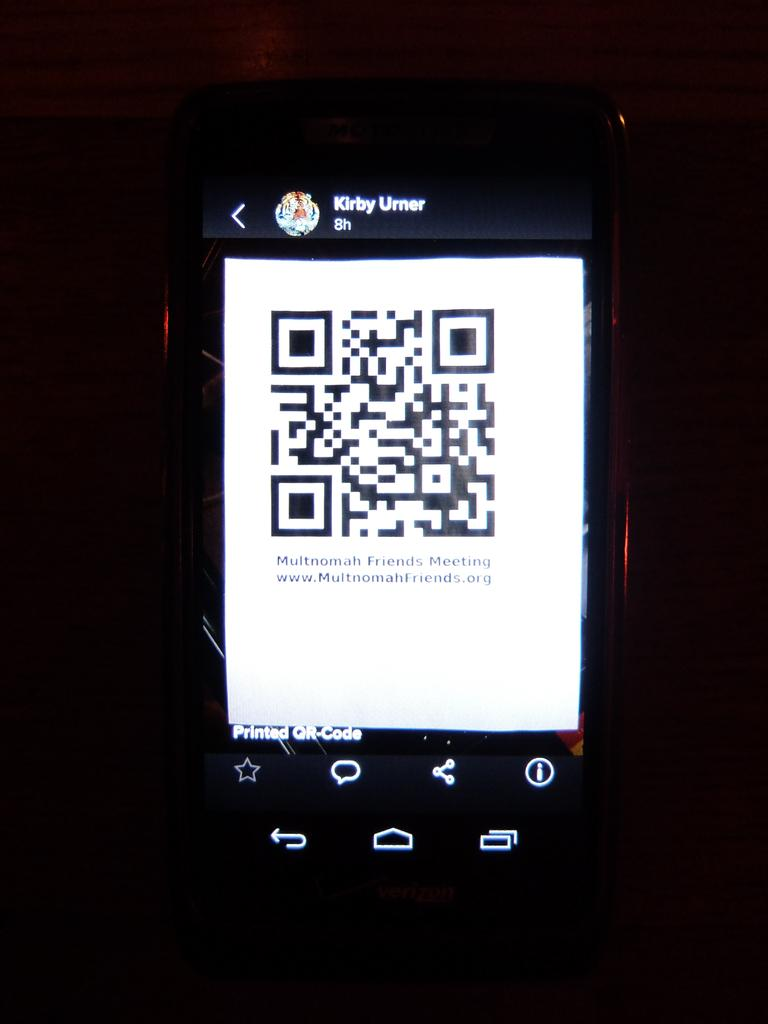Provide a one-sentence caption for the provided image. Kirby Umer shows a qr code on a cellphone. 